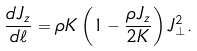Convert formula to latex. <formula><loc_0><loc_0><loc_500><loc_500>\frac { d J _ { z } } { d \ell } = \rho K \left ( 1 - \frac { \rho J _ { z } } { 2 K } \right ) J _ { \perp } ^ { 2 } .</formula> 